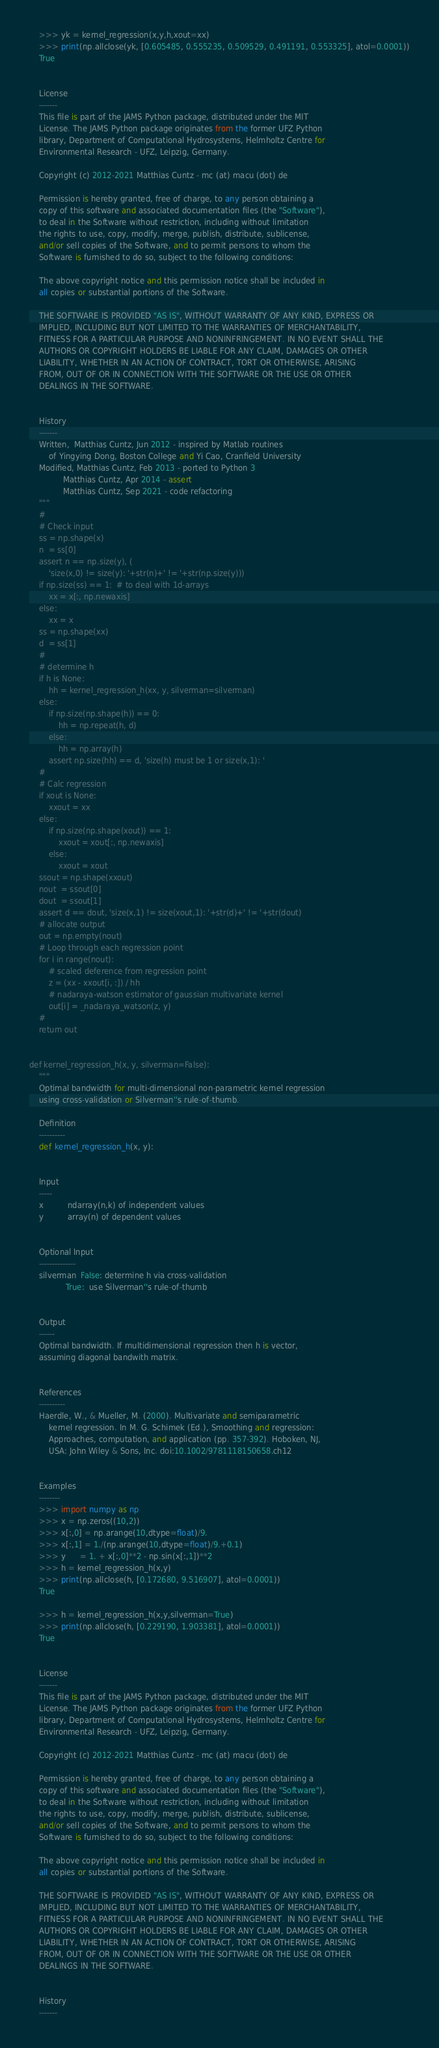<code> <loc_0><loc_0><loc_500><loc_500><_Python_>    >>> yk = kernel_regression(x,y,h,xout=xx)
    >>> print(np.allclose(yk, [0.605485, 0.555235, 0.509529, 0.491191, 0.553325], atol=0.0001))
    True


    License
    -------
    This file is part of the JAMS Python package, distributed under the MIT
    License. The JAMS Python package originates from the former UFZ Python
    library, Department of Computational Hydrosystems, Helmholtz Centre for
    Environmental Research - UFZ, Leipzig, Germany.

    Copyright (c) 2012-2021 Matthias Cuntz - mc (at) macu (dot) de

    Permission is hereby granted, free of charge, to any person obtaining a
    copy of this software and associated documentation files (the "Software"),
    to deal in the Software without restriction, including without limitation
    the rights to use, copy, modify, merge, publish, distribute, sublicense,
    and/or sell copies of the Software, and to permit persons to whom the
    Software is furnished to do so, subject to the following conditions:

    The above copyright notice and this permission notice shall be included in
    all copies or substantial portions of the Software.

    THE SOFTWARE IS PROVIDED "AS IS", WITHOUT WARRANTY OF ANY KIND, EXPRESS OR
    IMPLIED, INCLUDING BUT NOT LIMITED TO THE WARRANTIES OF MERCHANTABILITY,
    FITNESS FOR A PARTICULAR PURPOSE AND NONINFRINGEMENT. IN NO EVENT SHALL THE
    AUTHORS OR COPYRIGHT HOLDERS BE LIABLE FOR ANY CLAIM, DAMAGES OR OTHER
    LIABILITY, WHETHER IN AN ACTION OF CONTRACT, TORT OR OTHERWISE, ARISING
    FROM, OUT OF OR IN CONNECTION WITH THE SOFTWARE OR THE USE OR OTHER
    DEALINGS IN THE SOFTWARE.


    History
    -------
    Written,  Matthias Cuntz, Jun 2012 - inspired by Matlab routines
        of Yingying Dong, Boston College and Yi Cao, Cranfield University
    Modified, Matthias Cuntz, Feb 2013 - ported to Python 3
              Matthias Cuntz, Apr 2014 - assert
              Matthias Cuntz, Sep 2021 - code refactoring
    """
    #
    # Check input
    ss = np.shape(x)
    n  = ss[0]
    assert n == np.size(y), (
        'size(x,0) != size(y): '+str(n)+' != '+str(np.size(y)))
    if np.size(ss) == 1:  # to deal with 1d-arrays
        xx = x[:, np.newaxis]
    else:
        xx = x
    ss = np.shape(xx)
    d  = ss[1]
    #
    # determine h
    if h is None:
        hh = kernel_regression_h(xx, y, silverman=silverman)
    else:
        if np.size(np.shape(h)) == 0:
            hh = np.repeat(h, d)
        else:
            hh = np.array(h)
        assert np.size(hh) == d, 'size(h) must be 1 or size(x,1): '
    #
    # Calc regression
    if xout is None:
        xxout = xx
    else:
        if np.size(np.shape(xout)) == 1:
            xxout = xout[:, np.newaxis]
        else:
            xxout = xout
    ssout = np.shape(xxout)
    nout  = ssout[0]
    dout  = ssout[1]
    assert d == dout, 'size(x,1) != size(xout,1): '+str(d)+' != '+str(dout)
    # allocate output
    out = np.empty(nout)
    # Loop through each regression point
    for i in range(nout):
        # scaled deference from regression point
        z = (xx - xxout[i, :]) / hh
        # nadaraya-watson estimator of gaussian multivariate kernel
        out[i] = _nadaraya_watson(z, y)
    #
    return out


def kernel_regression_h(x, y, silverman=False):
    """
    Optimal bandwidth for multi-dimensional non-parametric kernel regression
    using cross-validation or Silverman''s rule-of-thumb.

    Definition
    ----------
    def kernel_regression_h(x, y):


    Input
    -----
    x          ndarray(n,k) of independent values
    y          array(n) of dependent values


    Optional Input
    --------------
    silverman  False: determine h via cross-validation
               True:  use Silverman''s rule-of-thumb


    Output
    ------
    Optimal bandwidth. If multidimensional regression then h is vector,
    assuming diagonal bandwith matrix.


    References
    ----------
    Haerdle, W., & Mueller, M. (2000). Multivariate and semiparametric
        kernel regression. In M. G. Schimek (Ed.), Smoothing and regression:
        Approaches, computation, and application (pp. 357-392). Hoboken, NJ,
        USA: John Wiley & Sons, Inc. doi:10.1002/9781118150658.ch12


    Examples
    --------
    >>> import numpy as np
    >>> x = np.zeros((10,2))
    >>> x[:,0] = np.arange(10,dtype=float)/9.
    >>> x[:,1] = 1./(np.arange(10,dtype=float)/9.+0.1)
    >>> y      = 1. + x[:,0]**2 - np.sin(x[:,1])**2
    >>> h = kernel_regression_h(x,y)
    >>> print(np.allclose(h, [0.172680, 9.516907], atol=0.0001))
    True

    >>> h = kernel_regression_h(x,y,silverman=True)
    >>> print(np.allclose(h, [0.229190, 1.903381], atol=0.0001))
    True


    License
    -------
    This file is part of the JAMS Python package, distributed under the MIT
    License. The JAMS Python package originates from the former UFZ Python
    library, Department of Computational Hydrosystems, Helmholtz Centre for
    Environmental Research - UFZ, Leipzig, Germany.

    Copyright (c) 2012-2021 Matthias Cuntz - mc (at) macu (dot) de

    Permission is hereby granted, free of charge, to any person obtaining a
    copy of this software and associated documentation files (the "Software"),
    to deal in the Software without restriction, including without limitation
    the rights to use, copy, modify, merge, publish, distribute, sublicense,
    and/or sell copies of the Software, and to permit persons to whom the
    Software is furnished to do so, subject to the following conditions:

    The above copyright notice and this permission notice shall be included in
    all copies or substantial portions of the Software.

    THE SOFTWARE IS PROVIDED "AS IS", WITHOUT WARRANTY OF ANY KIND, EXPRESS OR
    IMPLIED, INCLUDING BUT NOT LIMITED TO THE WARRANTIES OF MERCHANTABILITY,
    FITNESS FOR A PARTICULAR PURPOSE AND NONINFRINGEMENT. IN NO EVENT SHALL THE
    AUTHORS OR COPYRIGHT HOLDERS BE LIABLE FOR ANY CLAIM, DAMAGES OR OTHER
    LIABILITY, WHETHER IN AN ACTION OF CONTRACT, TORT OR OTHERWISE, ARISING
    FROM, OUT OF OR IN CONNECTION WITH THE SOFTWARE OR THE USE OR OTHER
    DEALINGS IN THE SOFTWARE.


    History
    -------</code> 